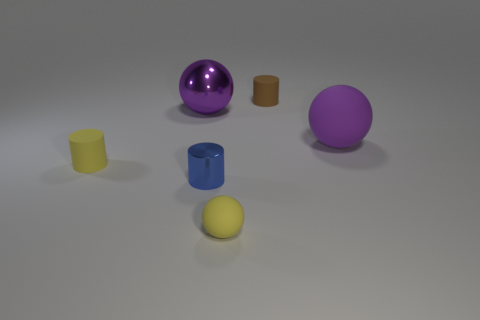Subtract all big metal balls. How many balls are left? 2 Subtract 3 cylinders. How many cylinders are left? 0 Add 4 big yellow shiny cylinders. How many objects exist? 10 Subtract all yellow blocks. How many gray cylinders are left? 0 Subtract all large metallic spheres. Subtract all small brown matte things. How many objects are left? 4 Add 5 large rubber balls. How many large rubber balls are left? 6 Add 3 small yellow things. How many small yellow things exist? 5 Subtract all yellow spheres. How many spheres are left? 2 Subtract 0 red cylinders. How many objects are left? 6 Subtract all gray spheres. Subtract all yellow blocks. How many spheres are left? 3 